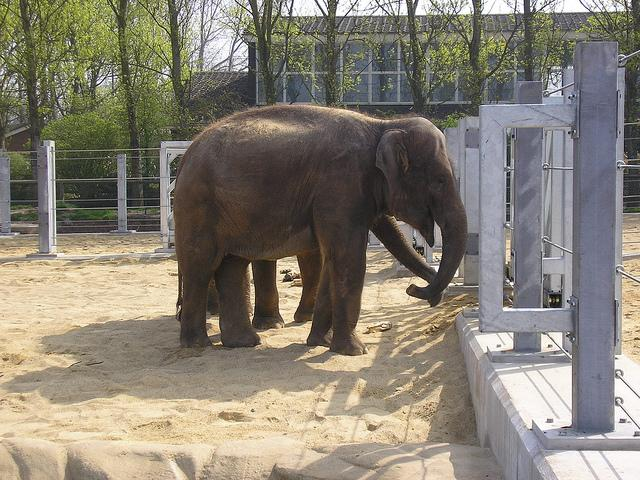What are the elephants standing in? sand 